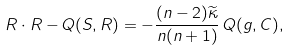<formula> <loc_0><loc_0><loc_500><loc_500>R \cdot R - Q ( S , R ) = - \frac { ( n - 2 ) \widetilde { \kappa } } { n ( n + 1 ) } \, Q ( g , C ) ,</formula> 